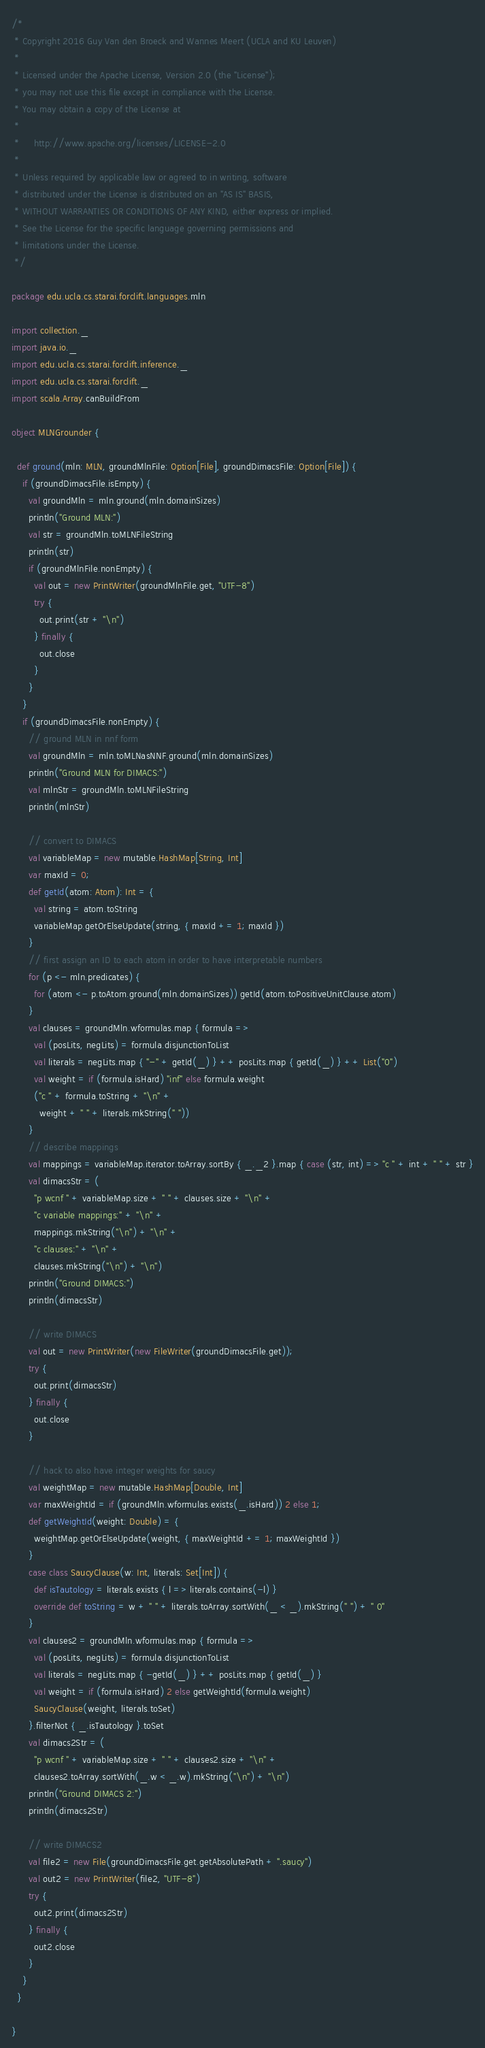<code> <loc_0><loc_0><loc_500><loc_500><_Scala_>/*
 * Copyright 2016 Guy Van den Broeck and Wannes Meert (UCLA and KU Leuven)
 *
 * Licensed under the Apache License, Version 2.0 (the "License");
 * you may not use this file except in compliance with the License.
 * You may obtain a copy of the License at
 *
 *     http://www.apache.org/licenses/LICENSE-2.0
 *
 * Unless required by applicable law or agreed to in writing, software
 * distributed under the License is distributed on an "AS IS" BASIS,
 * WITHOUT WARRANTIES OR CONDITIONS OF ANY KIND, either express or implied.
 * See the License for the specific language governing permissions and
 * limitations under the License.
 */

package edu.ucla.cs.starai.forclift.languages.mln

import collection._
import java.io._
import edu.ucla.cs.starai.forclift.inference._
import edu.ucla.cs.starai.forclift._
import scala.Array.canBuildFrom

object MLNGrounder {

  def ground(mln: MLN, groundMlnFile: Option[File], groundDimacsFile: Option[File]) {
    if (groundDimacsFile.isEmpty) {
      val groundMln = mln.ground(mln.domainSizes)
      println("Ground MLN:")
      val str = groundMln.toMLNFileString
      println(str)
      if (groundMlnFile.nonEmpty) {
        val out = new PrintWriter(groundMlnFile.get, "UTF-8")
        try {
          out.print(str + "\n")
        } finally {
          out.close
        }
      }
    }
    if (groundDimacsFile.nonEmpty) {
      // ground MLN in nnf form
      val groundMln = mln.toMLNasNNF.ground(mln.domainSizes)
      println("Ground MLN for DIMACS:")
      val mlnStr = groundMln.toMLNFileString
      println(mlnStr)

      // convert to DIMACS
      val variableMap = new mutable.HashMap[String, Int]
      var maxId = 0;
      def getId(atom: Atom): Int = {
        val string = atom.toString
        variableMap.getOrElseUpdate(string, { maxId += 1; maxId })
      }
      // first assign an ID to each atom in order to have interpretable numbers
      for (p <- mln.predicates) {
        for (atom <- p.toAtom.ground(mln.domainSizes)) getId(atom.toPositiveUnitClause.atom)
      }
      val clauses = groundMln.wformulas.map { formula =>
        val (posLits, negLits) = formula.disjunctionToList
        val literals = negLits.map { "-" + getId(_) } ++ posLits.map { getId(_) } ++ List("0")
        val weight = if (formula.isHard) "inf" else formula.weight
        ("c " + formula.toString + "\n" +
          weight + " " + literals.mkString(" "))
      }
      // describe mappings
      val mappings = variableMap.iterator.toArray.sortBy { _._2 }.map { case (str, int) => "c " + int + " " + str }
      val dimacsStr = (
        "p wcnf " + variableMap.size + " " + clauses.size + "\n" +
        "c variable mappings:" + "\n" +
        mappings.mkString("\n") + "\n" +
        "c clauses:" + "\n" +
        clauses.mkString("\n") + "\n")
      println("Ground DIMACS:")
      println(dimacsStr)

      // write DIMACS
      val out = new PrintWriter(new FileWriter(groundDimacsFile.get));
      try {
        out.print(dimacsStr)
      } finally {
        out.close
      }

      // hack to also have integer weights for saucy
      val weightMap = new mutable.HashMap[Double, Int]
      var maxWeightId = if (groundMln.wformulas.exists(_.isHard)) 2 else 1;
      def getWeightId(weight: Double) = {
        weightMap.getOrElseUpdate(weight, { maxWeightId += 1; maxWeightId })
      }
      case class SaucyClause(w: Int, literals: Set[Int]) {
        def isTautology = literals.exists { l => literals.contains(-l) }
        override def toString = w + " " + literals.toArray.sortWith(_ < _).mkString(" ") + " 0"
      }
      val clauses2 = groundMln.wformulas.map { formula =>
        val (posLits, negLits) = formula.disjunctionToList
        val literals = negLits.map { -getId(_) } ++ posLits.map { getId(_) }
        val weight = if (formula.isHard) 2 else getWeightId(formula.weight)
        SaucyClause(weight, literals.toSet)
      }.filterNot { _.isTautology }.toSet
      val dimacs2Str = (
        "p wcnf " + variableMap.size + " " + clauses2.size + "\n" +
        clauses2.toArray.sortWith(_.w < _.w).mkString("\n") + "\n")
      println("Ground DIMACS 2:")
      println(dimacs2Str)

      // write DIMACS2
      val file2 = new File(groundDimacsFile.get.getAbsolutePath + ".saucy")
      val out2 = new PrintWriter(file2, "UTF-8")
      try {
        out2.print(dimacs2Str)
      } finally {
        out2.close
      }
    }
  }

}
</code> 